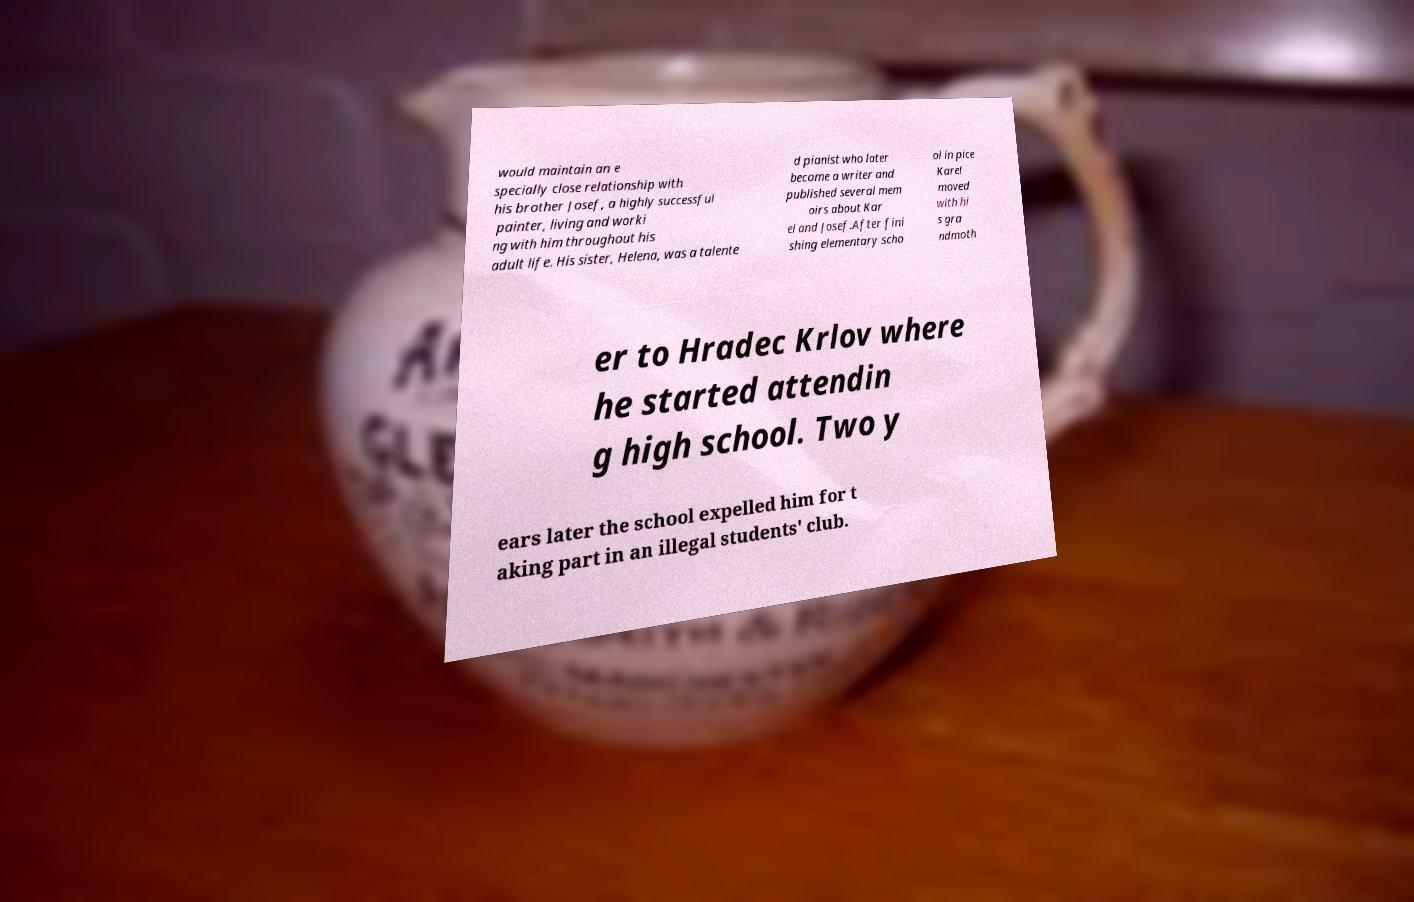Could you assist in decoding the text presented in this image and type it out clearly? would maintain an e specially close relationship with his brother Josef, a highly successful painter, living and worki ng with him throughout his adult life. His sister, Helena, was a talente d pianist who later become a writer and published several mem oirs about Kar el and Josef.After fini shing elementary scho ol in pice Karel moved with hi s gra ndmoth er to Hradec Krlov where he started attendin g high school. Two y ears later the school expelled him for t aking part in an illegal students' club. 